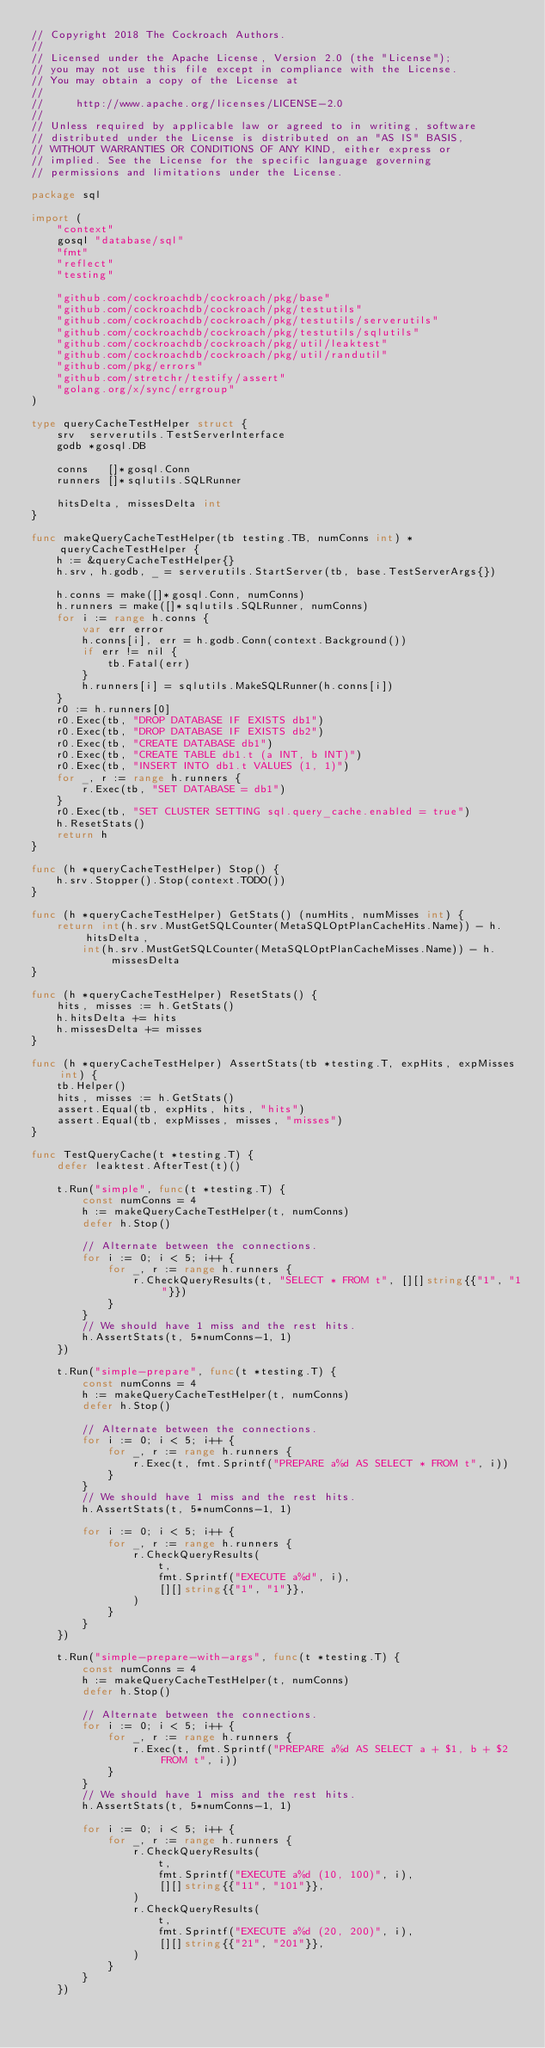<code> <loc_0><loc_0><loc_500><loc_500><_Go_>// Copyright 2018 The Cockroach Authors.
//
// Licensed under the Apache License, Version 2.0 (the "License");
// you may not use this file except in compliance with the License.
// You may obtain a copy of the License at
//
//     http://www.apache.org/licenses/LICENSE-2.0
//
// Unless required by applicable law or agreed to in writing, software
// distributed under the License is distributed on an "AS IS" BASIS,
// WITHOUT WARRANTIES OR CONDITIONS OF ANY KIND, either express or
// implied. See the License for the specific language governing
// permissions and limitations under the License.

package sql

import (
	"context"
	gosql "database/sql"
	"fmt"
	"reflect"
	"testing"

	"github.com/cockroachdb/cockroach/pkg/base"
	"github.com/cockroachdb/cockroach/pkg/testutils"
	"github.com/cockroachdb/cockroach/pkg/testutils/serverutils"
	"github.com/cockroachdb/cockroach/pkg/testutils/sqlutils"
	"github.com/cockroachdb/cockroach/pkg/util/leaktest"
	"github.com/cockroachdb/cockroach/pkg/util/randutil"
	"github.com/pkg/errors"
	"github.com/stretchr/testify/assert"
	"golang.org/x/sync/errgroup"
)

type queryCacheTestHelper struct {
	srv  serverutils.TestServerInterface
	godb *gosql.DB

	conns   []*gosql.Conn
	runners []*sqlutils.SQLRunner

	hitsDelta, missesDelta int
}

func makeQueryCacheTestHelper(tb testing.TB, numConns int) *queryCacheTestHelper {
	h := &queryCacheTestHelper{}
	h.srv, h.godb, _ = serverutils.StartServer(tb, base.TestServerArgs{})

	h.conns = make([]*gosql.Conn, numConns)
	h.runners = make([]*sqlutils.SQLRunner, numConns)
	for i := range h.conns {
		var err error
		h.conns[i], err = h.godb.Conn(context.Background())
		if err != nil {
			tb.Fatal(err)
		}
		h.runners[i] = sqlutils.MakeSQLRunner(h.conns[i])
	}
	r0 := h.runners[0]
	r0.Exec(tb, "DROP DATABASE IF EXISTS db1")
	r0.Exec(tb, "DROP DATABASE IF EXISTS db2")
	r0.Exec(tb, "CREATE DATABASE db1")
	r0.Exec(tb, "CREATE TABLE db1.t (a INT, b INT)")
	r0.Exec(tb, "INSERT INTO db1.t VALUES (1, 1)")
	for _, r := range h.runners {
		r.Exec(tb, "SET DATABASE = db1")
	}
	r0.Exec(tb, "SET CLUSTER SETTING sql.query_cache.enabled = true")
	h.ResetStats()
	return h
}

func (h *queryCacheTestHelper) Stop() {
	h.srv.Stopper().Stop(context.TODO())
}

func (h *queryCacheTestHelper) GetStats() (numHits, numMisses int) {
	return int(h.srv.MustGetSQLCounter(MetaSQLOptPlanCacheHits.Name)) - h.hitsDelta,
		int(h.srv.MustGetSQLCounter(MetaSQLOptPlanCacheMisses.Name)) - h.missesDelta
}

func (h *queryCacheTestHelper) ResetStats() {
	hits, misses := h.GetStats()
	h.hitsDelta += hits
	h.missesDelta += misses
}

func (h *queryCacheTestHelper) AssertStats(tb *testing.T, expHits, expMisses int) {
	tb.Helper()
	hits, misses := h.GetStats()
	assert.Equal(tb, expHits, hits, "hits")
	assert.Equal(tb, expMisses, misses, "misses")
}

func TestQueryCache(t *testing.T) {
	defer leaktest.AfterTest(t)()

	t.Run("simple", func(t *testing.T) {
		const numConns = 4
		h := makeQueryCacheTestHelper(t, numConns)
		defer h.Stop()

		// Alternate between the connections.
		for i := 0; i < 5; i++ {
			for _, r := range h.runners {
				r.CheckQueryResults(t, "SELECT * FROM t", [][]string{{"1", "1"}})
			}
		}
		// We should have 1 miss and the rest hits.
		h.AssertStats(t, 5*numConns-1, 1)
	})

	t.Run("simple-prepare", func(t *testing.T) {
		const numConns = 4
		h := makeQueryCacheTestHelper(t, numConns)
		defer h.Stop()

		// Alternate between the connections.
		for i := 0; i < 5; i++ {
			for _, r := range h.runners {
				r.Exec(t, fmt.Sprintf("PREPARE a%d AS SELECT * FROM t", i))
			}
		}
		// We should have 1 miss and the rest hits.
		h.AssertStats(t, 5*numConns-1, 1)

		for i := 0; i < 5; i++ {
			for _, r := range h.runners {
				r.CheckQueryResults(
					t,
					fmt.Sprintf("EXECUTE a%d", i),
					[][]string{{"1", "1"}},
				)
			}
		}
	})

	t.Run("simple-prepare-with-args", func(t *testing.T) {
		const numConns = 4
		h := makeQueryCacheTestHelper(t, numConns)
		defer h.Stop()

		// Alternate between the connections.
		for i := 0; i < 5; i++ {
			for _, r := range h.runners {
				r.Exec(t, fmt.Sprintf("PREPARE a%d AS SELECT a + $1, b + $2 FROM t", i))
			}
		}
		// We should have 1 miss and the rest hits.
		h.AssertStats(t, 5*numConns-1, 1)

		for i := 0; i < 5; i++ {
			for _, r := range h.runners {
				r.CheckQueryResults(
					t,
					fmt.Sprintf("EXECUTE a%d (10, 100)", i),
					[][]string{{"11", "101"}},
				)
				r.CheckQueryResults(
					t,
					fmt.Sprintf("EXECUTE a%d (20, 200)", i),
					[][]string{{"21", "201"}},
				)
			}
		}
	})
</code> 